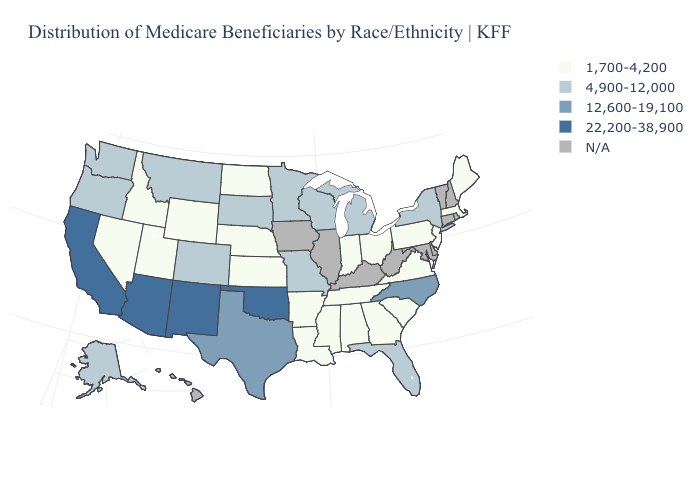What is the highest value in the USA?
Quick response, please. 22,200-38,900. Is the legend a continuous bar?
Be succinct. No. Name the states that have a value in the range 4,900-12,000?
Give a very brief answer. Alaska, Colorado, Florida, Michigan, Minnesota, Missouri, Montana, New York, Oregon, South Dakota, Washington, Wisconsin. Among the states that border Nevada , does Oregon have the highest value?
Answer briefly. No. Among the states that border Utah , which have the lowest value?
Give a very brief answer. Idaho, Nevada, Wyoming. Name the states that have a value in the range 22,200-38,900?
Answer briefly. Arizona, California, New Mexico, Oklahoma. Among the states that border Indiana , does Ohio have the lowest value?
Write a very short answer. Yes. What is the highest value in states that border Oklahoma?
Concise answer only. 22,200-38,900. What is the value of Rhode Island?
Give a very brief answer. N/A. Name the states that have a value in the range N/A?
Be succinct. Connecticut, Delaware, Hawaii, Illinois, Iowa, Kentucky, Maryland, New Hampshire, Rhode Island, Vermont, West Virginia. Among the states that border Indiana , does Ohio have the highest value?
Short answer required. No. Does the first symbol in the legend represent the smallest category?
Short answer required. Yes. Does Oklahoma have the highest value in the USA?
Short answer required. Yes. 